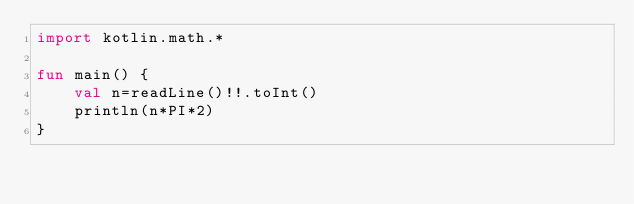Convert code to text. <code><loc_0><loc_0><loc_500><loc_500><_Kotlin_>import kotlin.math.*

fun main() {
	val n=readLine()!!.toInt()
	println(n*PI*2)
}
</code> 